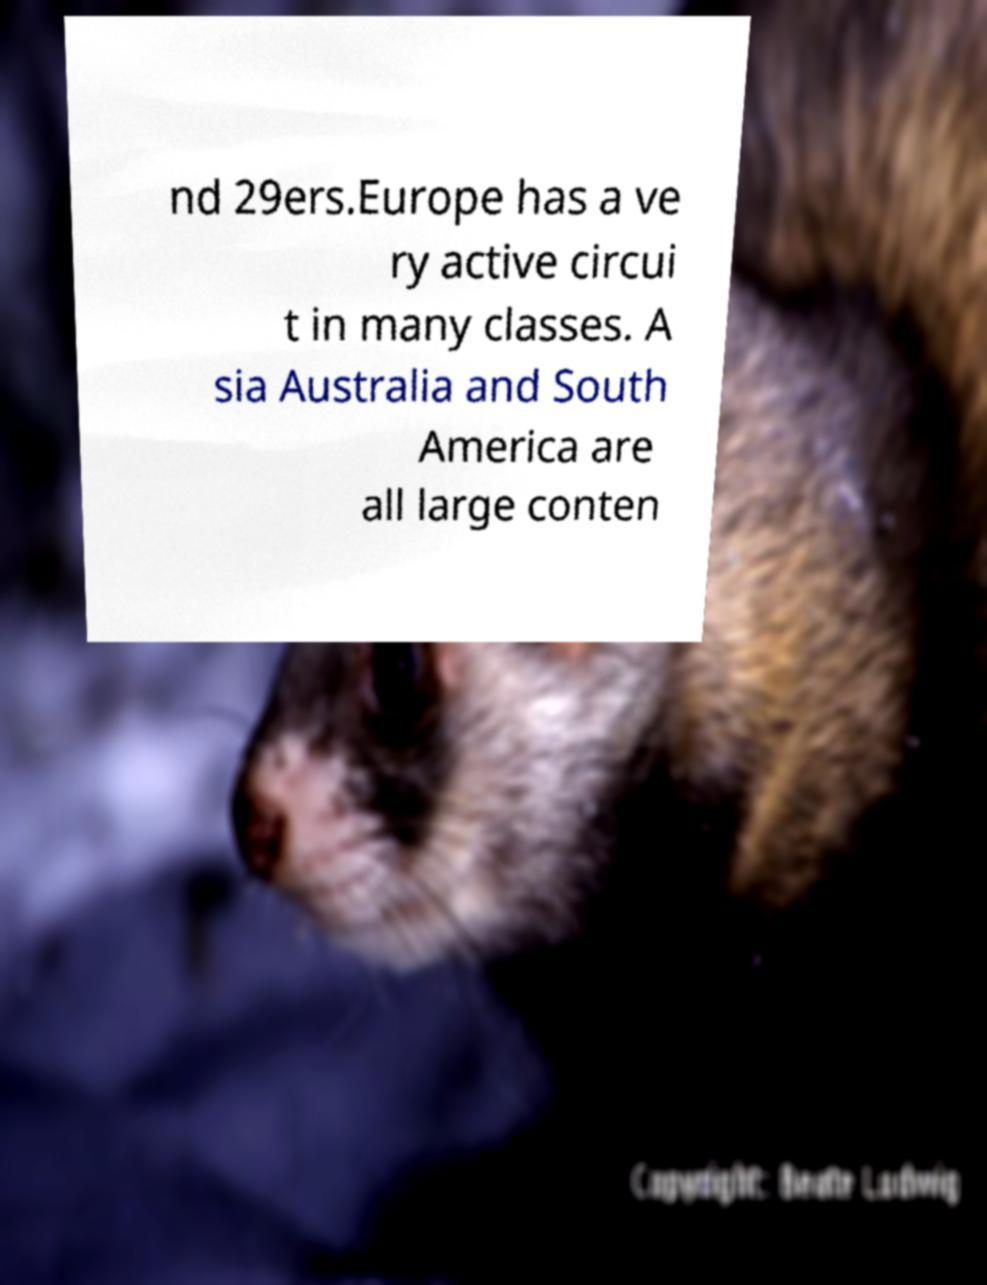Please read and relay the text visible in this image. What does it say? nd 29ers.Europe has a ve ry active circui t in many classes. A sia Australia and South America are all large conten 